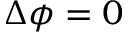<formula> <loc_0><loc_0><loc_500><loc_500>\Delta \phi = 0</formula> 